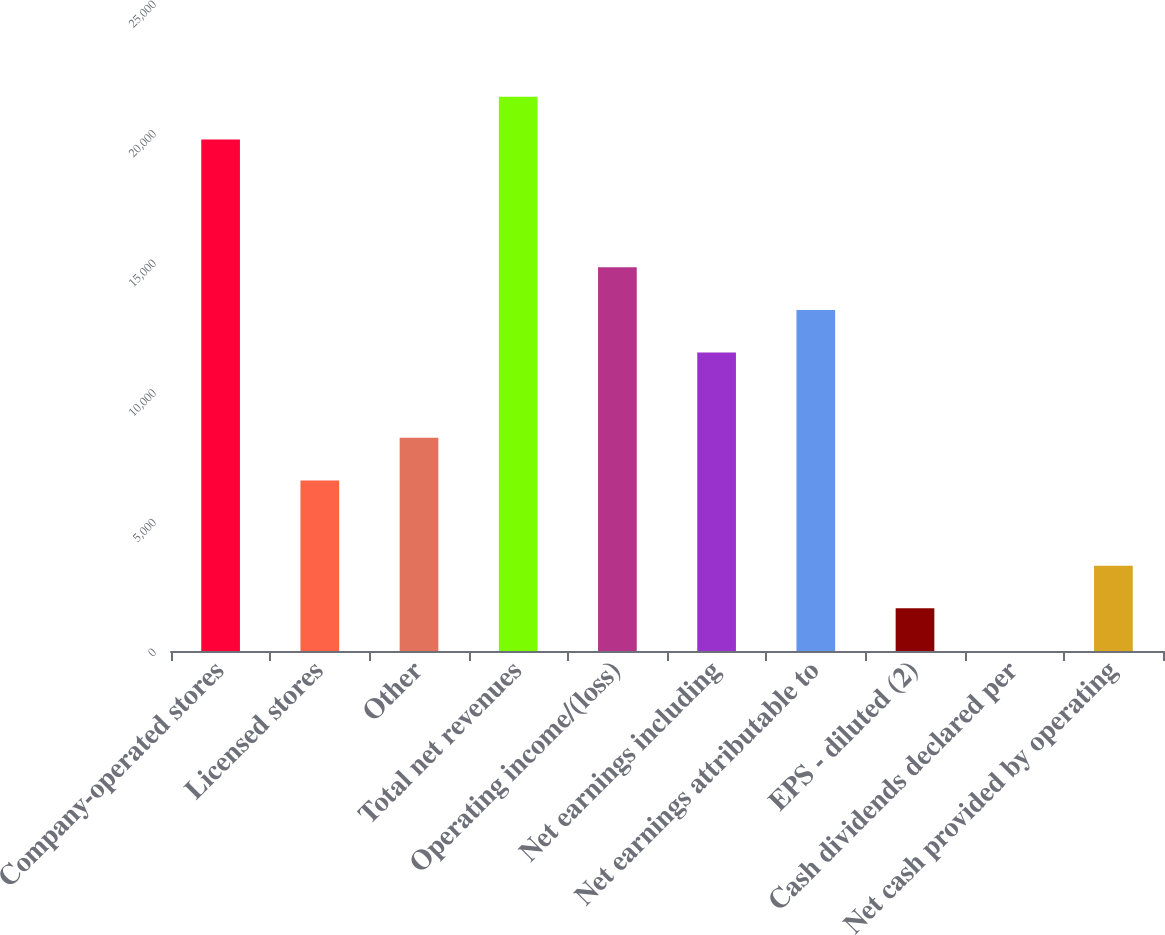Convert chart to OTSL. <chart><loc_0><loc_0><loc_500><loc_500><bar_chart><fcel>Company-operated stores<fcel>Licensed stores<fcel>Other<fcel>Total net revenues<fcel>Operating income/(loss)<fcel>Net earnings including<fcel>Net earnings attributable to<fcel>EPS - diluted (2)<fcel>Cash dividends declared per<fcel>Net cash provided by operating<nl><fcel>19737.3<fcel>6579.47<fcel>8224.19<fcel>21382<fcel>14803.1<fcel>11513.6<fcel>13158.4<fcel>1645.28<fcel>0.55<fcel>3290.01<nl></chart> 